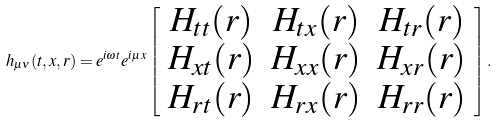<formula> <loc_0><loc_0><loc_500><loc_500>h _ { \mu \nu } ( t , x , r ) = e ^ { i \omega t } e ^ { i \mu x } \left [ \begin{array} { c c c } H _ { t t } ( r ) & H _ { t x } ( r ) & H _ { t r } ( r ) \\ H _ { x t } ( r ) & H _ { x x } ( r ) & H _ { x r } ( r ) \\ H _ { r t } ( r ) & H _ { r x } ( r ) & H _ { r r } ( r ) \\ \end{array} \right ] .</formula> 